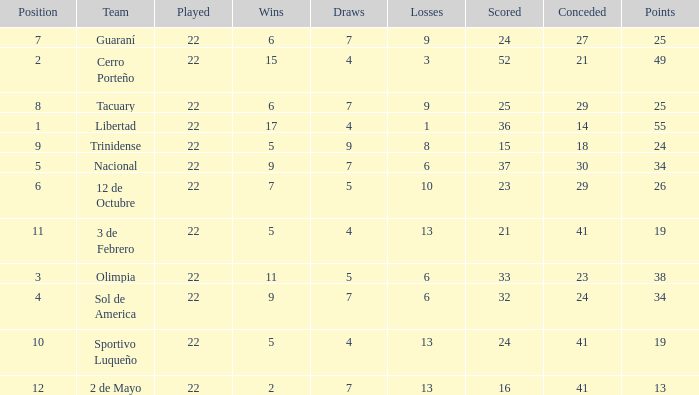What is the fewest wins that has fewer than 23 goals scored, team of 2 de Mayo, and fewer than 7 draws? None. 